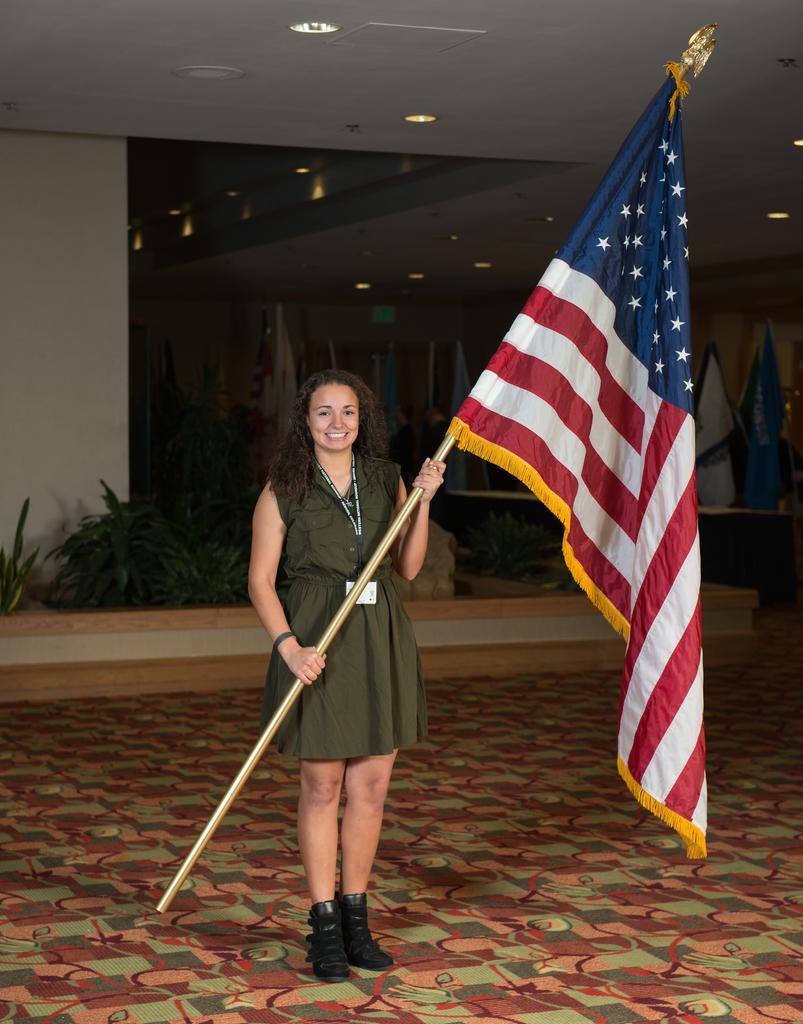Could you give a brief overview of what you see in this image? In this picture we can see a woman standing on the floor and holding a pole of a flag and in the background we can see flags, lights, plants. 